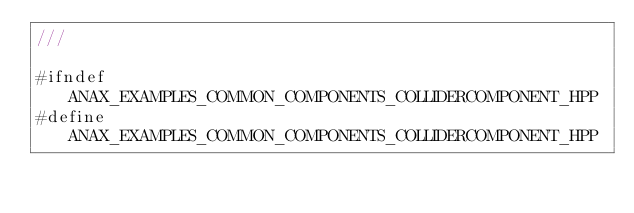Convert code to text. <code><loc_0><loc_0><loc_500><loc_500><_C++_>///

#ifndef ANAX_EXAMPLES_COMMON_COMPONENTS_COLLIDERCOMPONENT_HPP
#define ANAX_EXAMPLES_COMMON_COMPONENTS_COLLIDERCOMPONENT_HPP
</code> 